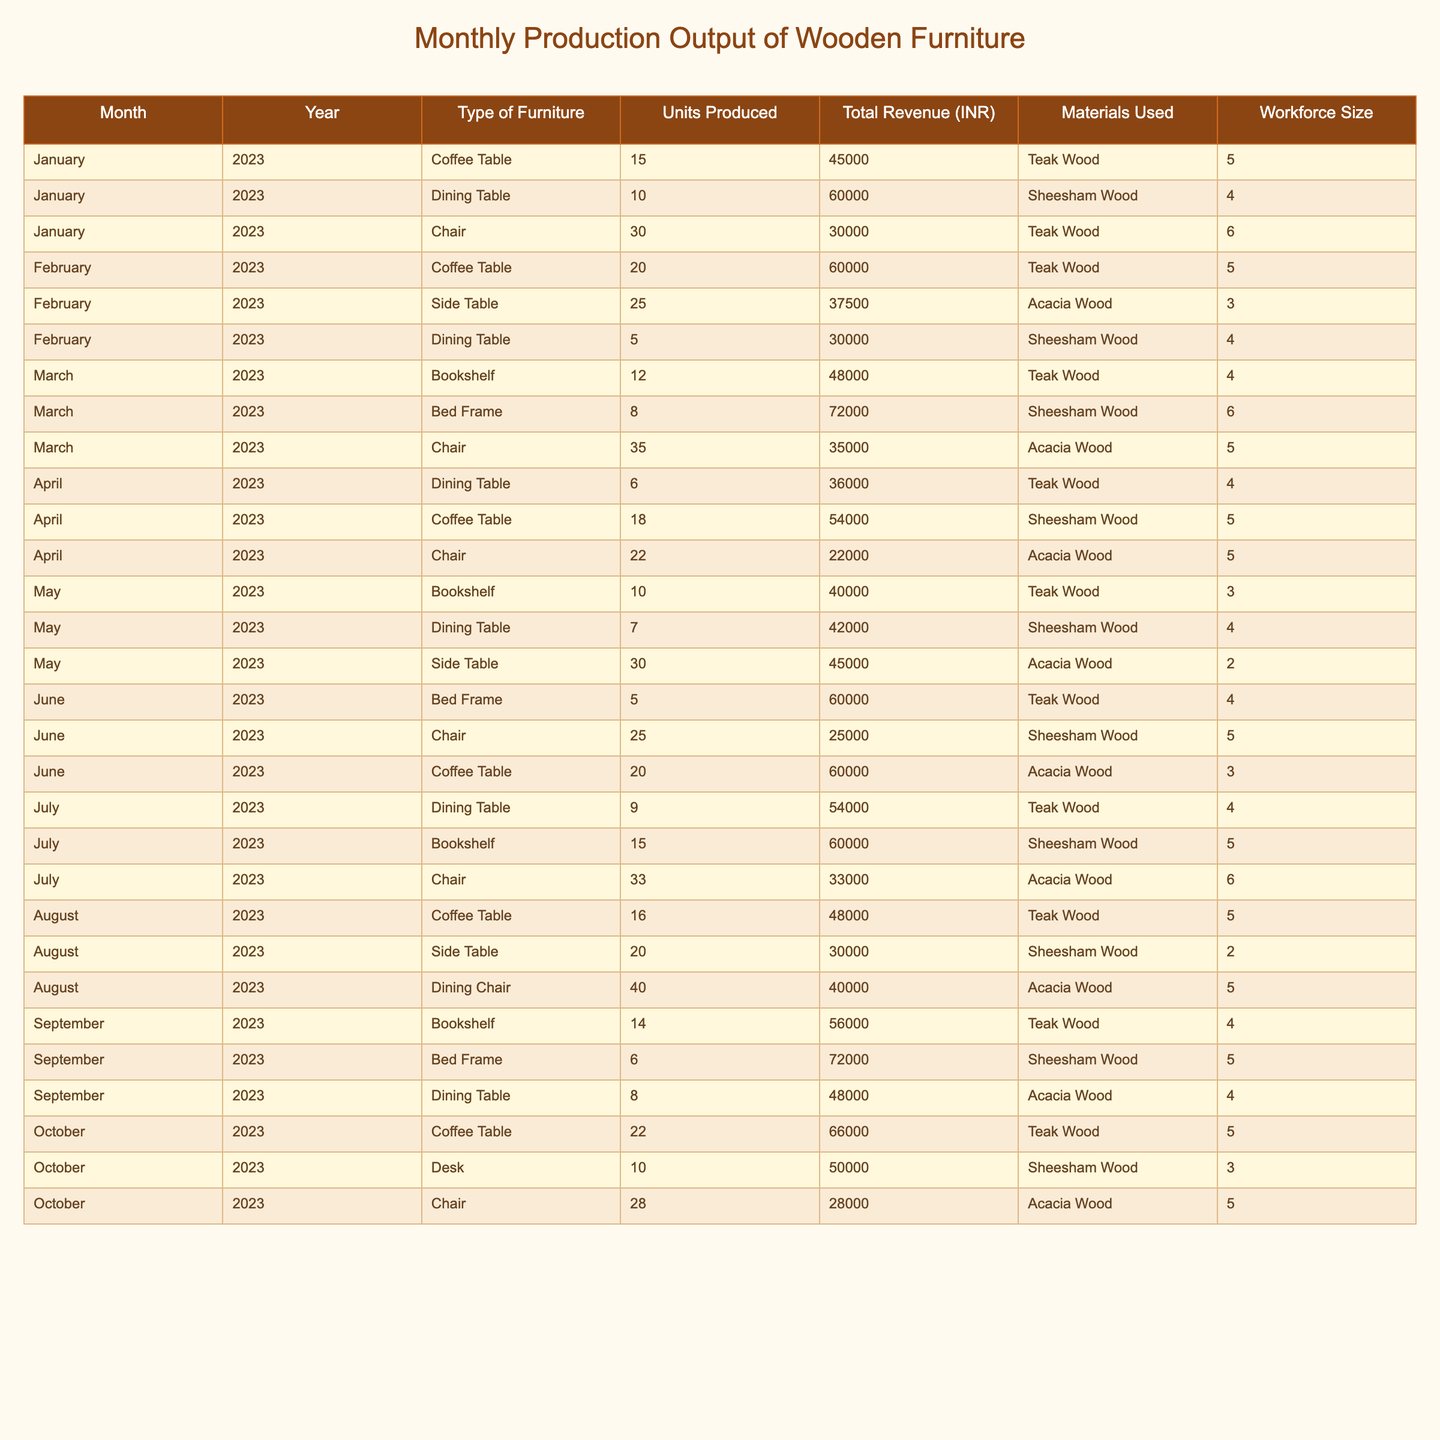What is the total number of Coffee Tables produced in March 2023? From the table, we can look at the row for March 2023 and find that the number of Coffee Tables produced is 0, as there is no entry for Coffee Tables in that month.
Answer: 0 What was the total revenue generated from Dining Tables in February 2023? In February 2023, Dining Tables produced 5 units, generating a total revenue of 30,000 INR.
Answer: 30,000 INR Which type of furniture had the highest units produced in July 2023? In July 2023, the Chair type had 33 units produced, which is the highest compared to Coffee Tables (16), Side Tables (0), Bookshelves (15), and Dining Tables (9).
Answer: Chair What was the average number of units produced for Bookshelves across all months? Summing the units produced for Bookshelves: 12 (March) + 10 (May) + 15 (July) + 14 (September) = 51 units. Then, dividing by the number of months (4), we get 51/4 = 12.75.
Answer: 12.75 Did the production of Chairs consistently increase from January to October 2023? Looking at the units produced for Chairs: 30 (January), 35 (March), 22 (April), 25 (June), 33 (July), and 28 (October), we see fluctuations rather than a consistent increase.
Answer: No What is the total workforce size used for producing Dining Tables from January to April 2023? The workforce sizes for Dining Tables are: 4 (January) + 4 (February) + 4 (April) + 4 (March) + 4 (April) = 16 workers used across these months.
Answer: 16 Which month saw the highest revenue from Side Tables, and what was the amount? From the table, February produced 25 units of Side Tables, generating 37,500 INR, which is the only entry for Side Tables and the highest revenue for that type since no other Side Table entries are available in other months.
Answer: February 2023, 37,500 INR What is the total number of units produced for all types of furniture in October 2023? Summing all produced furniture in October: Coffee Table (22) + Desk (10) + Chair (28) = 60 units in total.
Answer: 60 Which material was used most frequently for the production of Chairs? The materials for Chairs are Teak Wood (January), Acacia Wood (March), and Sheesham Wood (June, July, October), with Acacia Wood appearing three times and the others only once.
Answer: Acacia Wood What was the increase or decrease in production of Bed Frames from June to September 2023? In June, 5 units were produced, and in September, 6 units were produced, indicating an increase of 1 unit.
Answer: Increase of 1 unit What is the total revenue earned from all furniture types produced in January 2023? January 2023 had total revenues of 45,000 (Coffee Table) + 60,000 (Dining Table) + 30,000 (Chair) = 135,000 INR.
Answer: 135,000 INR 